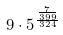<formula> <loc_0><loc_0><loc_500><loc_500>9 \cdot 5 ^ { \frac { \frac { 7 } { 3 9 9 } } { 3 2 4 } }</formula> 